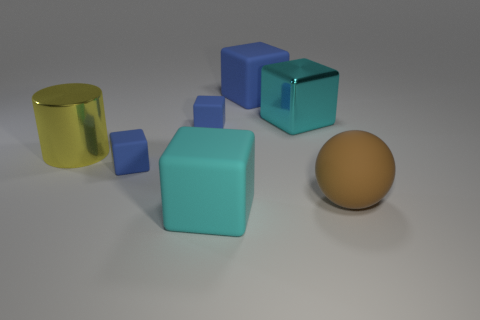Subtract all blue cubes. How many were subtracted if there are1blue cubes left? 2 Subtract all tiny cubes. How many cubes are left? 3 Add 2 large cylinders. How many objects exist? 9 Subtract all blue blocks. How many blocks are left? 2 Subtract all balls. How many objects are left? 6 Subtract all green cubes. Subtract all red balls. How many cubes are left? 5 Subtract all green cylinders. How many cyan cubes are left? 2 Subtract all large yellow cylinders. Subtract all large objects. How many objects are left? 1 Add 2 large cyan shiny blocks. How many large cyan shiny blocks are left? 3 Add 5 red metal balls. How many red metal balls exist? 5 